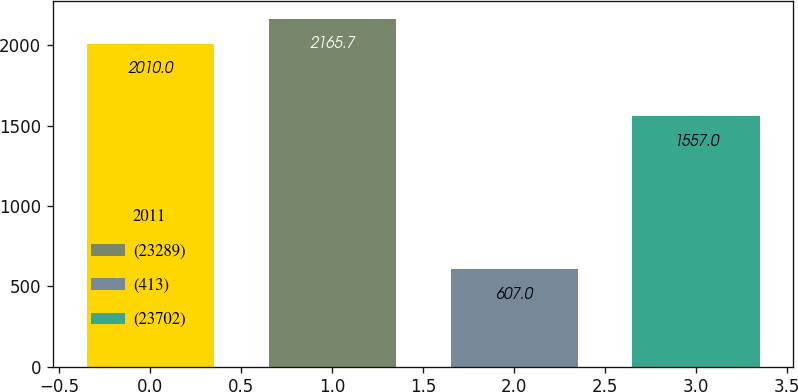Convert chart. <chart><loc_0><loc_0><loc_500><loc_500><bar_chart><fcel>2011<fcel>(23289)<fcel>(413)<fcel>(23702)<nl><fcel>2010<fcel>2165.7<fcel>607<fcel>1557<nl></chart> 